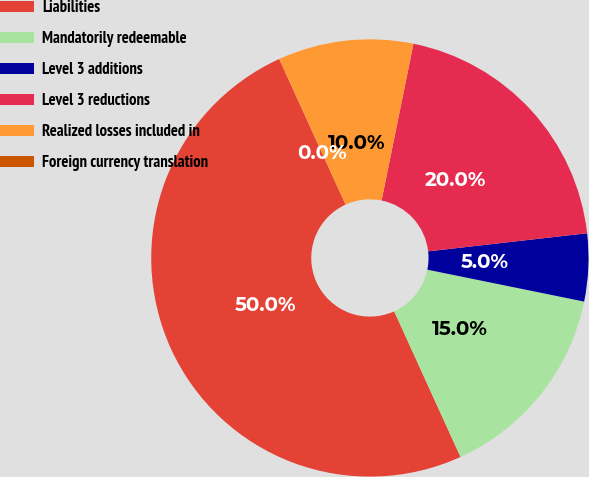<chart> <loc_0><loc_0><loc_500><loc_500><pie_chart><fcel>Liabilities<fcel>Mandatorily redeemable<fcel>Level 3 additions<fcel>Level 3 reductions<fcel>Realized losses included in<fcel>Foreign currency translation<nl><fcel>50.0%<fcel>15.0%<fcel>5.0%<fcel>20.0%<fcel>10.0%<fcel>0.0%<nl></chart> 